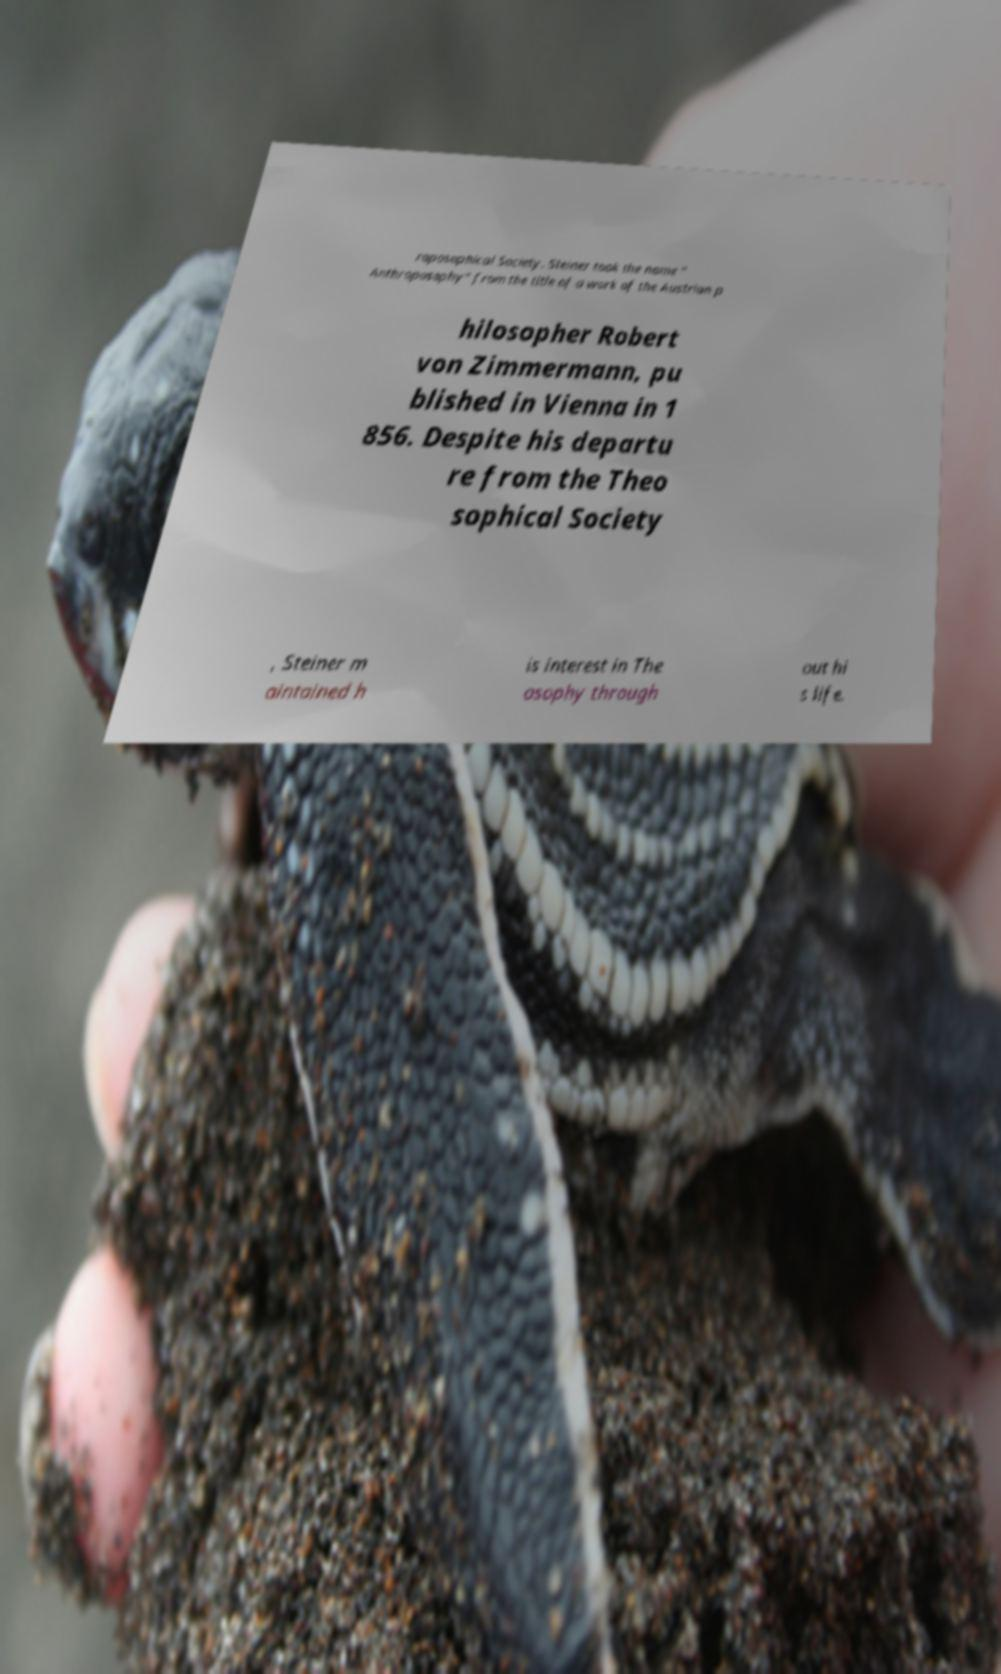Could you assist in decoding the text presented in this image and type it out clearly? roposophical Society. Steiner took the name " Anthroposophy" from the title of a work of the Austrian p hilosopher Robert von Zimmermann, pu blished in Vienna in 1 856. Despite his departu re from the Theo sophical Society , Steiner m aintained h is interest in The osophy through out hi s life. 